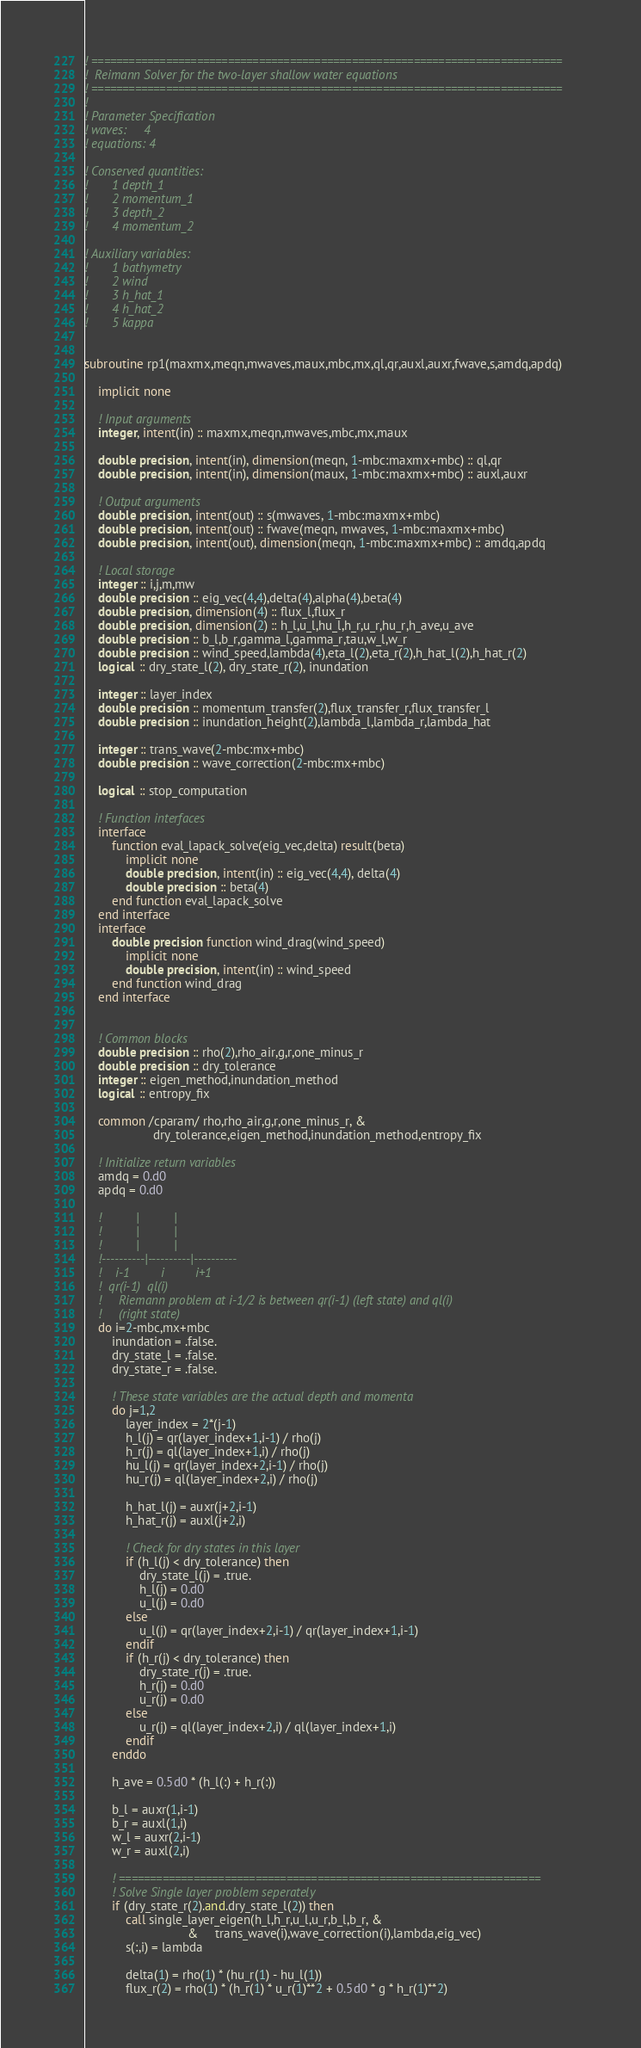Convert code to text. <code><loc_0><loc_0><loc_500><loc_500><_FORTRAN_>! ============================================================================
!  Reimann Solver for the two-layer shallow water equations
! ============================================================================
!
! Parameter Specification
! waves:     4
! equations: 4

! Conserved quantities:
!       1 depth_1
!       2 momentum_1
!       3 depth_2
!       4 momentum_2

! Auxiliary variables:
!       1 bathymetry
!       2 wind
!       3 h_hat_1
!       4 h_hat_2
!       5 kappa


subroutine rp1(maxmx,meqn,mwaves,maux,mbc,mx,ql,qr,auxl,auxr,fwave,s,amdq,apdq)

    implicit none
    
    ! Input arguments
    integer, intent(in) :: maxmx,meqn,mwaves,mbc,mx,maux
    
    double precision, intent(in), dimension(meqn, 1-mbc:maxmx+mbc) :: ql,qr
    double precision, intent(in), dimension(maux, 1-mbc:maxmx+mbc) :: auxl,auxr
    
    ! Output arguments
    double precision, intent(out) :: s(mwaves, 1-mbc:maxmx+mbc)
    double precision, intent(out) :: fwave(meqn, mwaves, 1-mbc:maxmx+mbc)
    double precision, intent(out), dimension(meqn, 1-mbc:maxmx+mbc) :: amdq,apdq
    
    ! Local storage
    integer :: i,j,m,mw
    double precision :: eig_vec(4,4),delta(4),alpha(4),beta(4)
    double precision, dimension(4) :: flux_l,flux_r
    double precision, dimension(2) :: h_l,u_l,hu_l,h_r,u_r,hu_r,h_ave,u_ave
    double precision :: b_l,b_r,gamma_l,gamma_r,tau,w_l,w_r
    double precision :: wind_speed,lambda(4),eta_l(2),eta_r(2),h_hat_l(2),h_hat_r(2)
    logical :: dry_state_l(2), dry_state_r(2), inundation
    
    integer :: layer_index
    double precision :: momentum_transfer(2),flux_transfer_r,flux_transfer_l
    double precision :: inundation_height(2),lambda_l,lambda_r,lambda_hat

    integer :: trans_wave(2-mbc:mx+mbc)
    double precision :: wave_correction(2-mbc:mx+mbc)
    
    logical :: stop_computation

    ! Function interfaces
    interface
        function eval_lapack_solve(eig_vec,delta) result(beta)
            implicit none
            double precision, intent(in) :: eig_vec(4,4), delta(4)
            double precision :: beta(4)
        end function eval_lapack_solve
    end interface
    interface
        double precision function wind_drag(wind_speed)
            implicit none
            double precision, intent(in) :: wind_speed
        end function wind_drag
    end interface
    

    ! Common blocks
    double precision :: rho(2),rho_air,g,r,one_minus_r
    double precision :: dry_tolerance
    integer :: eigen_method,inundation_method
    logical :: entropy_fix
    
    common /cparam/ rho,rho_air,g,r,one_minus_r, &
                    dry_tolerance,eigen_method,inundation_method,entropy_fix

    ! Initialize return variables
    amdq = 0.d0
    apdq = 0.d0

    !          |          |          
    !          |          |          
    !          |          |          
    !----------|----------|----------
    !    i-1         i         i+1
    !  qr(i-1)  ql(i)
    !     Riemann problem at i-1/2 is between qr(i-1) (left state) and ql(i) 
    !     (right state)
    do i=2-mbc,mx+mbc
        inundation = .false.
        dry_state_l = .false.
        dry_state_r = .false.
        
        ! These state variables are the actual depth and momenta
        do j=1,2
            layer_index = 2*(j-1)
            h_l(j) = qr(layer_index+1,i-1) / rho(j)
            h_r(j) = ql(layer_index+1,i) / rho(j)
            hu_l(j) = qr(layer_index+2,i-1) / rho(j)
            hu_r(j) = ql(layer_index+2,i) / rho(j)
            
            h_hat_l(j) = auxr(j+2,i-1)
            h_hat_r(j) = auxl(j+2,i)
            
            ! Check for dry states in this layer
            if (h_l(j) < dry_tolerance) then
                dry_state_l(j) = .true.
                h_l(j) = 0.d0
                u_l(j) = 0.d0
            else
                u_l(j) = qr(layer_index+2,i-1) / qr(layer_index+1,i-1)
            endif
            if (h_r(j) < dry_tolerance) then
                dry_state_r(j) = .true.
                h_r(j) = 0.d0
                u_r(j) = 0.d0
            else
                u_r(j) = ql(layer_index+2,i) / ql(layer_index+1,i)
            endif
        enddo
        
        h_ave = 0.5d0 * (h_l(:) + h_r(:))
        
        b_l = auxr(1,i-1)
        b_r = auxl(1,i)
        w_l = auxr(2,i-1)
        w_r = auxl(2,i)      
            
        ! ====================================================================
        ! Solve Single layer problem seperately
        if (dry_state_r(2).and.dry_state_l(2)) then
            call single_layer_eigen(h_l,h_r,u_l,u_r,b_l,b_r, &
                              &     trans_wave(i),wave_correction(i),lambda,eig_vec)
            s(:,i) = lambda
            
            delta(1) = rho(1) * (hu_r(1) - hu_l(1))
            flux_r(2) = rho(1) * (h_r(1) * u_r(1)**2 + 0.5d0 * g * h_r(1)**2)</code> 